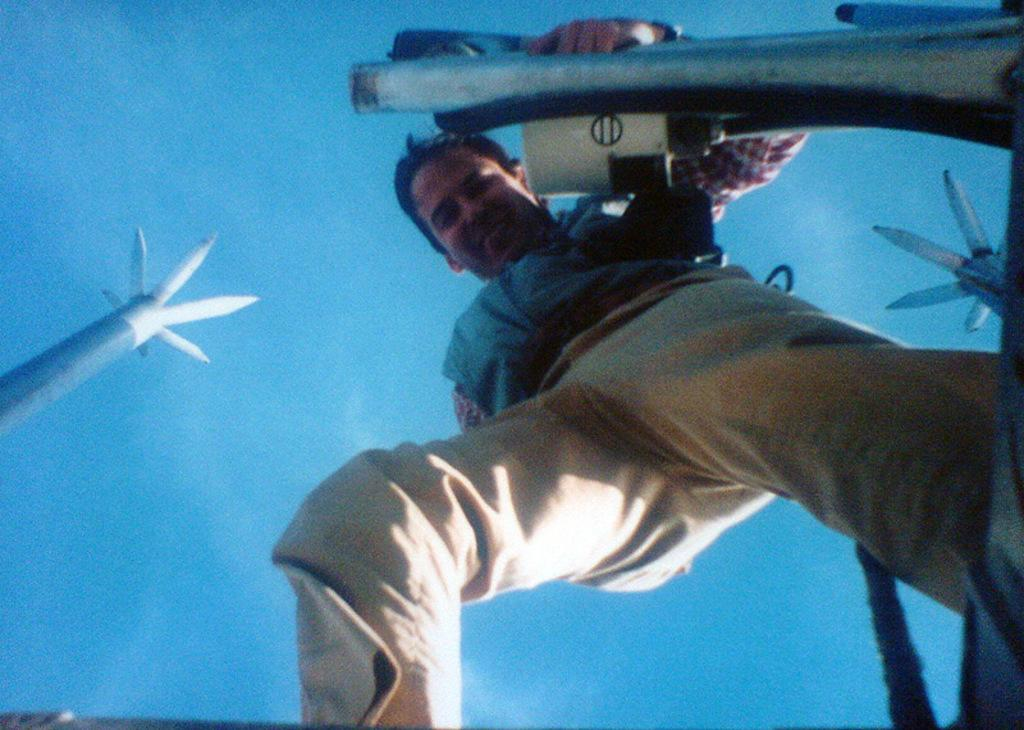What is the main subject of the image? The main subject of the image is a man. What is the man doing in the image? The man is standing and smiling in the image. What can be seen in the background of the image? There are poles and a cloudy sky visible in the background. What is the man holding in the image? The man is holding a white object. Can you see any jellyfish in the image? No, there are no jellyfish present in the image. What type of finger is the man using to hold the white object? There is no mention of a finger in the image; the man is simply holding a white object. 